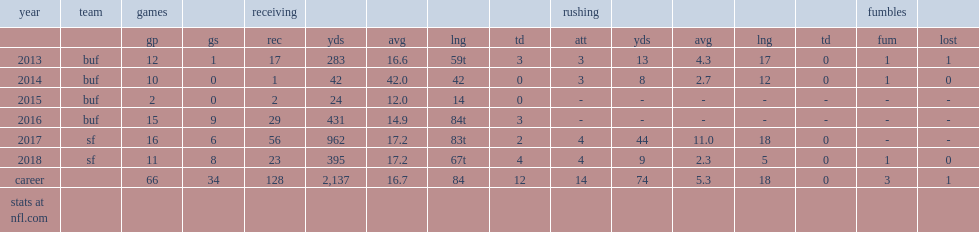How many receiving yards did goodwin get in 2017? 962.0. 